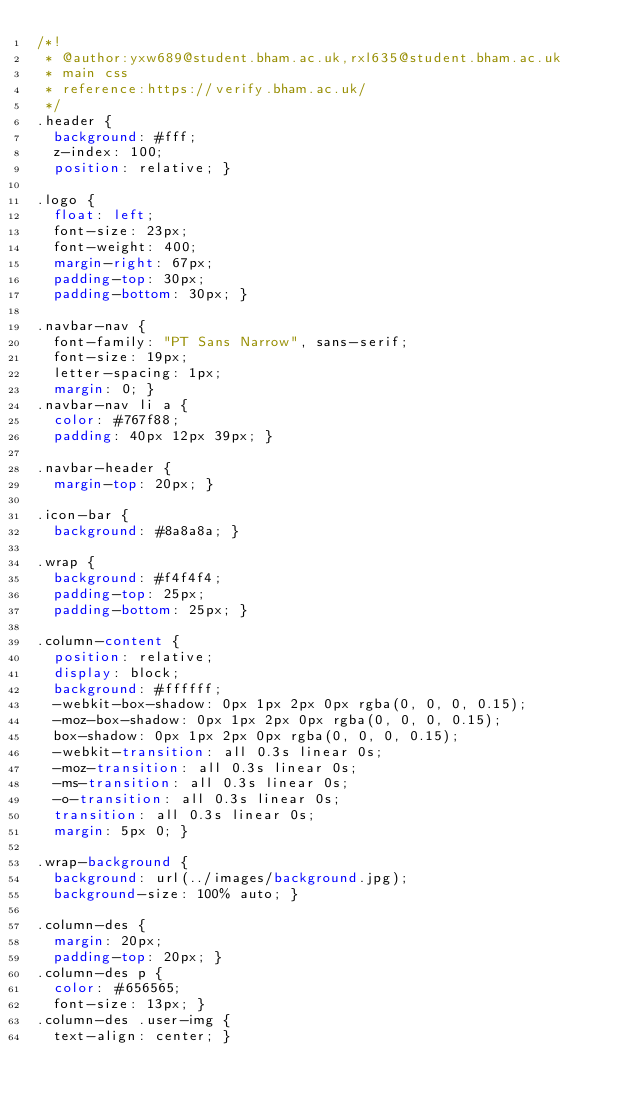Convert code to text. <code><loc_0><loc_0><loc_500><loc_500><_CSS_>/*!
 * @author:yxw689@student.bham.ac.uk,rxl635@student.bham.ac.uk
 * main css
 * reference:https://verify.bham.ac.uk/
 */
.header {
  background: #fff;
  z-index: 100;
  position: relative; }

.logo {
  float: left;
  font-size: 23px;
  font-weight: 400;
  margin-right: 67px;
  padding-top: 30px;
  padding-bottom: 30px; }

.navbar-nav {
  font-family: "PT Sans Narrow", sans-serif;
  font-size: 19px;
  letter-spacing: 1px;
  margin: 0; }
.navbar-nav li a {
  color: #767f88;
  padding: 40px 12px 39px; }

.navbar-header {
  margin-top: 20px; }

.icon-bar {
  background: #8a8a8a; }

.wrap {
  background: #f4f4f4;
  padding-top: 25px;
  padding-bottom: 25px; }

.column-content {
  position: relative;
  display: block;
  background: #ffffff;
  -webkit-box-shadow: 0px 1px 2px 0px rgba(0, 0, 0, 0.15);
  -moz-box-shadow: 0px 1px 2px 0px rgba(0, 0, 0, 0.15);
  box-shadow: 0px 1px 2px 0px rgba(0, 0, 0, 0.15);
  -webkit-transition: all 0.3s linear 0s;
  -moz-transition: all 0.3s linear 0s;
  -ms-transition: all 0.3s linear 0s;
  -o-transition: all 0.3s linear 0s;
  transition: all 0.3s linear 0s;
  margin: 5px 0; }

.wrap-background {
  background: url(../images/background.jpg);
  background-size: 100% auto; }

.column-des {
  margin: 20px;
  padding-top: 20px; }
.column-des p {
  color: #656565;
  font-size: 13px; }
.column-des .user-img {
  text-align: center; }</code> 